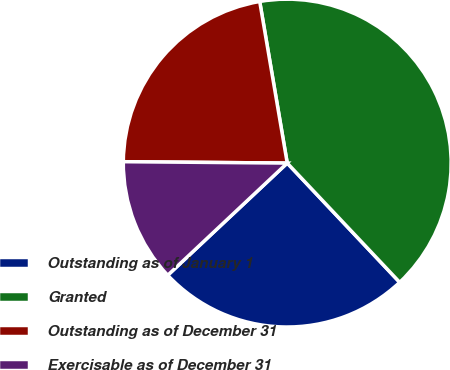<chart> <loc_0><loc_0><loc_500><loc_500><pie_chart><fcel>Outstanding as of January 1<fcel>Granted<fcel>Outstanding as of December 31<fcel>Exercisable as of December 31<nl><fcel>25.04%<fcel>40.65%<fcel>22.18%<fcel>12.13%<nl></chart> 